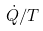Convert formula to latex. <formula><loc_0><loc_0><loc_500><loc_500>\dot { Q } / T</formula> 